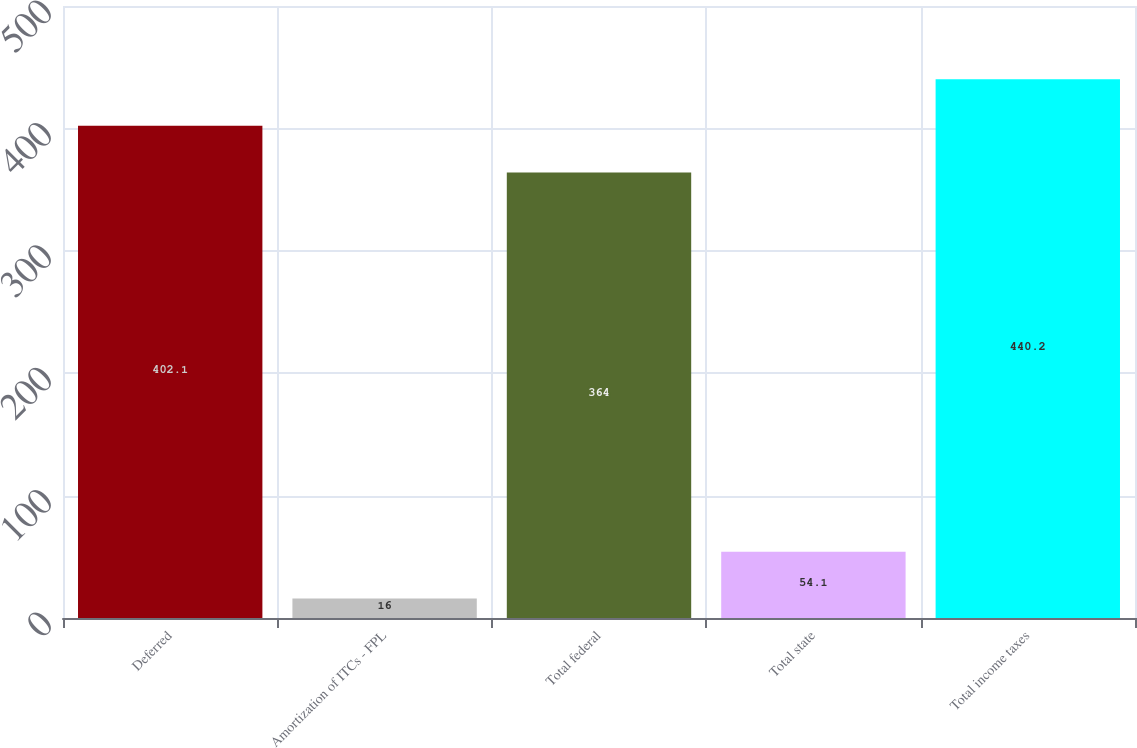Convert chart to OTSL. <chart><loc_0><loc_0><loc_500><loc_500><bar_chart><fcel>Deferred<fcel>Amortization of ITCs - FPL<fcel>Total federal<fcel>Total state<fcel>Total income taxes<nl><fcel>402.1<fcel>16<fcel>364<fcel>54.1<fcel>440.2<nl></chart> 